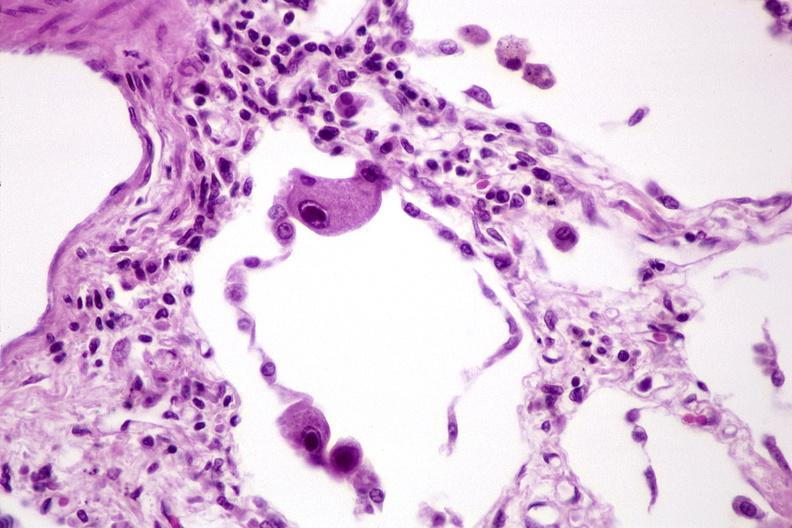does bone, skull show lung, cyomegalovirus pneumonia?
Answer the question using a single word or phrase. No 